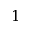Convert formula to latex. <formula><loc_0><loc_0><loc_500><loc_500>1</formula> 